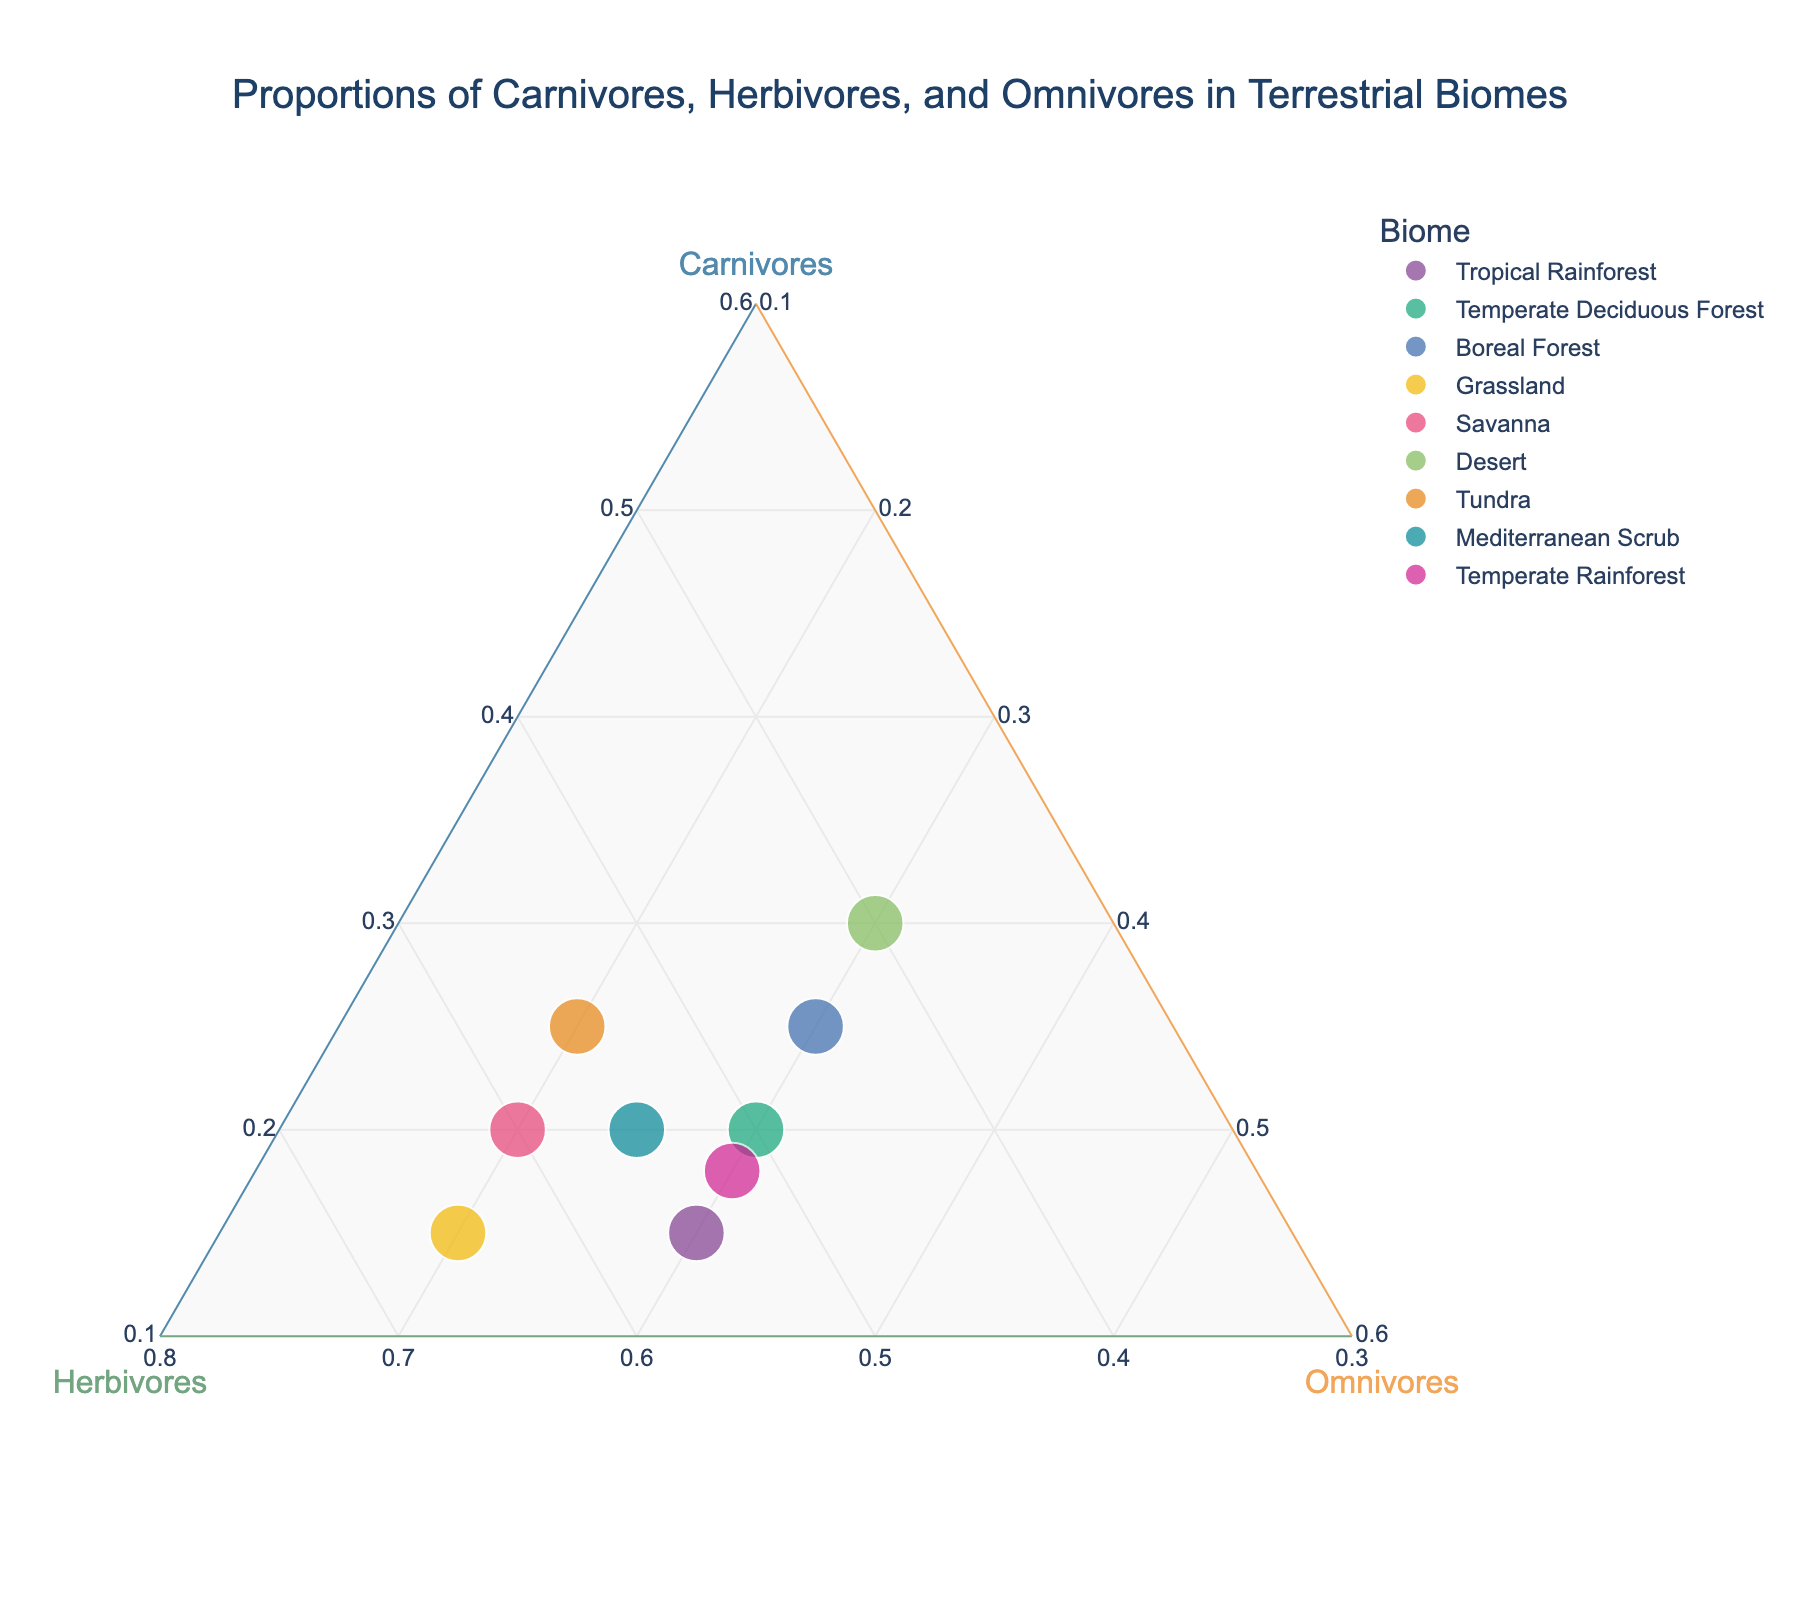What is the title of the figure? The title is generally placed at the top of the figure and provides a description of the plot. The title of this figure is "Proportions of Carnivores, Herbivores, and Omnivores in Terrestrial Biomes".
Answer: Proportions of Carnivores, Herbivores, and Omnivores in Terrestrial Biomes Which biome has the highest proportion of carnivores? By examining the vertices of the ternary plot, we can identify the point closest to the 'Carnivores' vertex. Upon checking the data, the Desert biome has the highest carnivore proportion at 0.30.
Answer: Desert Which biomes have equal proportions of omnivores? By inspecting the omnivore axis and identifying points aligned horizontally, we find that Tropical Rainforest, Temperate Deciduous Forest, Boreal Forest, and Temperate Rainforest all have 0.30 proportion of omnivores.
Answer: Tropical Rainforest, Temperate Deciduous Forest, Boreal Forest, Temperate Rainforest What is the sum of the carnivores and herbivores proportions in the Grassland biome? In the Grassland biome, the carnivore proportion is 0.15 and the herbivore proportion is 0.65. Adding these proportions: 0.15 + 0.65 = 0.80.
Answer: 0.80 Which biome has the smallest proportion of omnivores? By identifying the point closest to the 'Herbivores' and 'Carnivores' vertices, the Grassland and Savanna biomes each have the lowest omnivore proportion: 0.20.
Answer: Grassland and Savanna Which biomes have equal proportions of carnivores? By examining the carnivore axis, the points aligned horizontally indicate equal proportions. The Tropical Rainforest and Grassland have 0.15 carnivores, and the Temperate Deciduous Forest, Savanna, and Mediterranean Scrub all have 0.20 carnivores.
Answer: Tropical Rainforest and Grassland; Temperate Deciduous Forest, Savanna, and Mediterranean Scrub Compare the proportions of herbivores between the Tropical Rainforest and Boreal Forest biomes. Checking the herbivore axis, the Tropical Rainforest has a herbivore proportion of 0.55, while the Boreal Forest has 0.45. The Tropical Rainforest has a higher proportion of herbivores.
Answer: Tropical Rainforest has a higher herbivore proportion What is the average proportion of herbivores across all the biomes? Summing the herbivore proportions: 0.55 + 0.50 + 0.45 + 0.65 + 0.60 + 0.40 + 0.55 + 0.55 + 0.52 = 4.77. Dividing by the number of biomes (9): 4.77 / 9 = 0.53.
Answer: 0.53 Is there any biome where all three categories (carnivores, herbivores, omnivores) have equal proportions? Checking the proportions, none of the biomes show equal proportions for all three categories.
Answer: No 